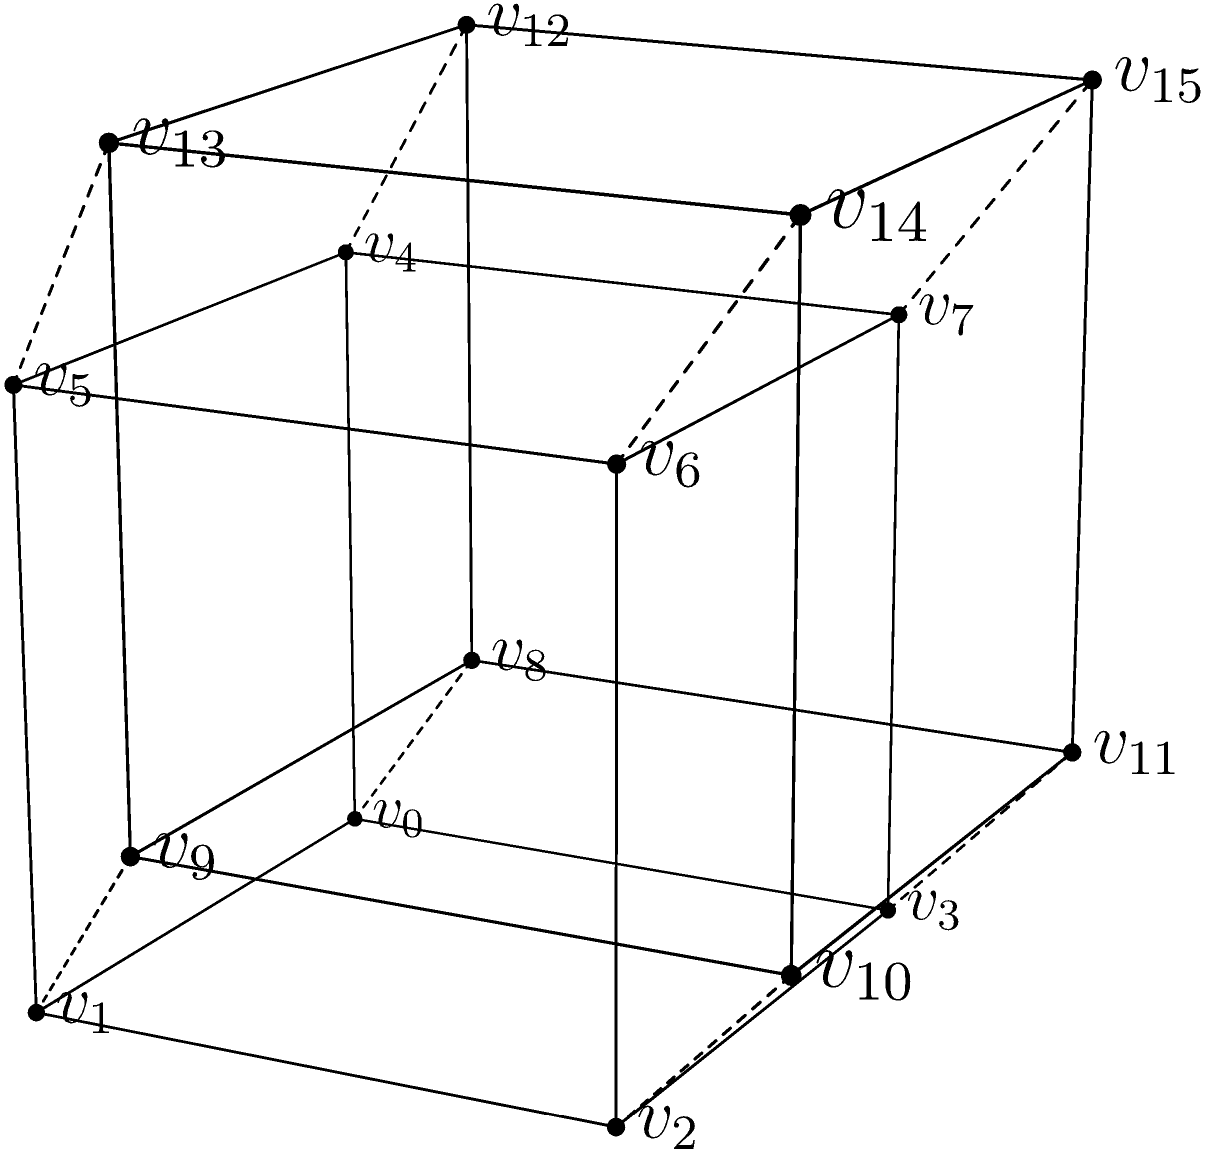In your latest sci-fi novel, you're describing a tesseract-inspired spaceship. The ship's design is based on the projection of a 4D hypercube (tesseract) onto 3D space. If the ship's control room is located at vertex $v_0$ and the engine room at vertex $v_{15}$, what is the minimum number of edges that must be traversed to move from the control room to the engine room in this 3D projection? To solve this problem, we need to understand the structure of the tesseract projection in 3D space:

1. In a tesseract, each vertex is connected to four other vertices.
2. The projection shows the tesseract as two cubes (inner and outer) connected by edges.
3. $v_0$ is a vertex of the inner cube, while $v_{15}$ is a vertex of the outer cube.

To find the shortest path:

1. Start at $v_0$ (inner cube).
2. Move to $v_8$, which is the corresponding vertex on the outer cube. This takes 1 edge.
3. On the outer cube, we need to move to $v_{15}$, which is diagonally opposite $v_8$.
4. To reach $v_{15}$ from $v_8$ on the outer cube, we need to traverse 3 edges (moving along the cube's edges).

Therefore, the total number of edges traversed is:
1 (from inner to outer cube) + 3 (on the outer cube) = 4 edges

This represents the shortest path in the 3D projection of the tesseract between $v_0$ and $v_{15}$.
Answer: 4 edges 